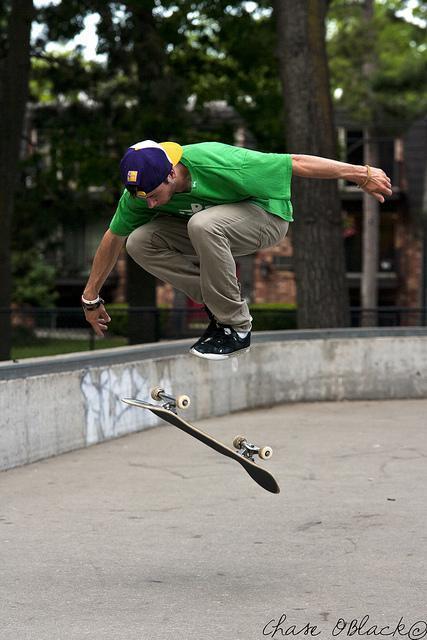How many bus riders are leaning out of a bus window?
Give a very brief answer. 0. 